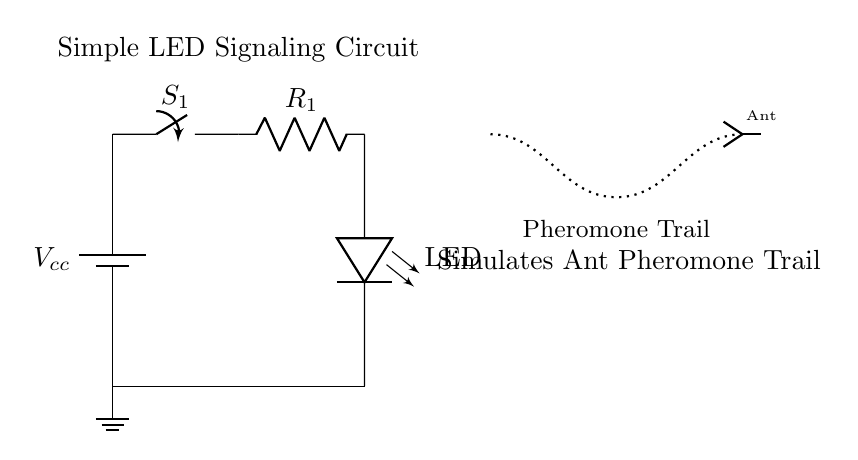What type of circuit is this? This is a signaling circuit designed to simulate pheromone trails, as indicated by the title and description in the diagram.
Answer: Signaling circuit What component is used to light up in this circuit? The LED is the component that lights up when the circuit is energized, as shown in the diagram where it is connected at the output of the resistor.
Answer: LED What does the switch do in this circuit? The switch controls the flow of electricity; when it is closed, it allows current to pass and the LED to light up. When it is open, the circuit is incomplete, and the LED stays off.
Answer: Controls current flow What is the purpose of the resistor? The resistor limits the amount of current flowing to the LED to prevent it from burning out, ensuring that it receives the appropriate level of voltage and current.
Answer: Current limiting If the battery voltage is 5 volts, what voltage is across the LED? The LED is in the circuit path after the resistor, so it should have a reduced voltage depending on the resistor's value. Typically, LED forward voltage is around 1.8 to 3.3 volts, assuming ideal conditions and design.
Answer: Approximately 1.8 to 3.3 volts Which way does current flow in this circuit? Current flows from the positive terminal of the battery, through the switch, then the resistor, before illuminating the LED, and finally returning to the ground. This flow is established by the completed circuit path.
Answer: Positive to ground What does the dotted line represent in this circuit? The dotted line symbolizes the simulated pheromone trail visually, indicating the path the ants would take in nature and how the LED indicates that trail to signify the pheromone signal.
Answer: Pheromone trail 